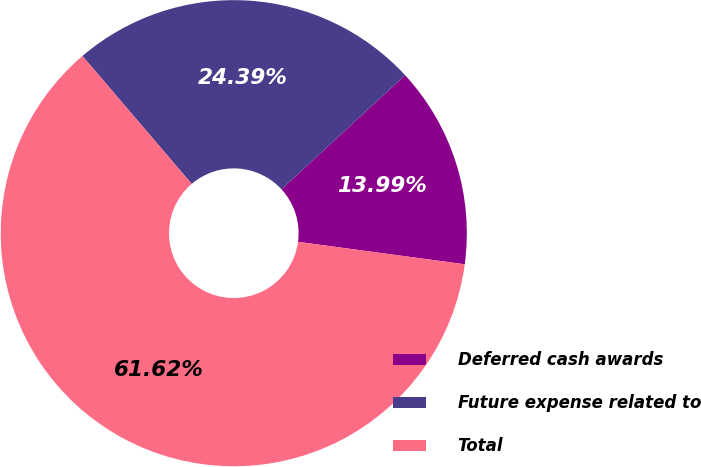<chart> <loc_0><loc_0><loc_500><loc_500><pie_chart><fcel>Deferred cash awards<fcel>Future expense related to<fcel>Total<nl><fcel>13.99%<fcel>24.39%<fcel>61.62%<nl></chart> 